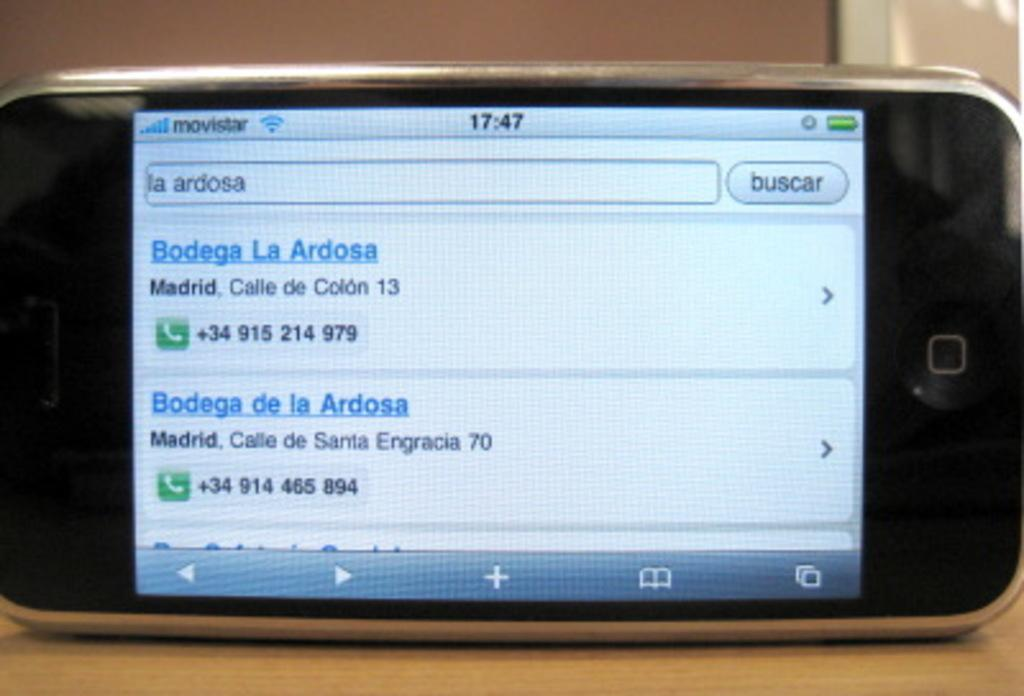Provide a one-sentence caption for the provided image. A phone screen that is showing an internet browser that has numbers of a bodega pulled up. 